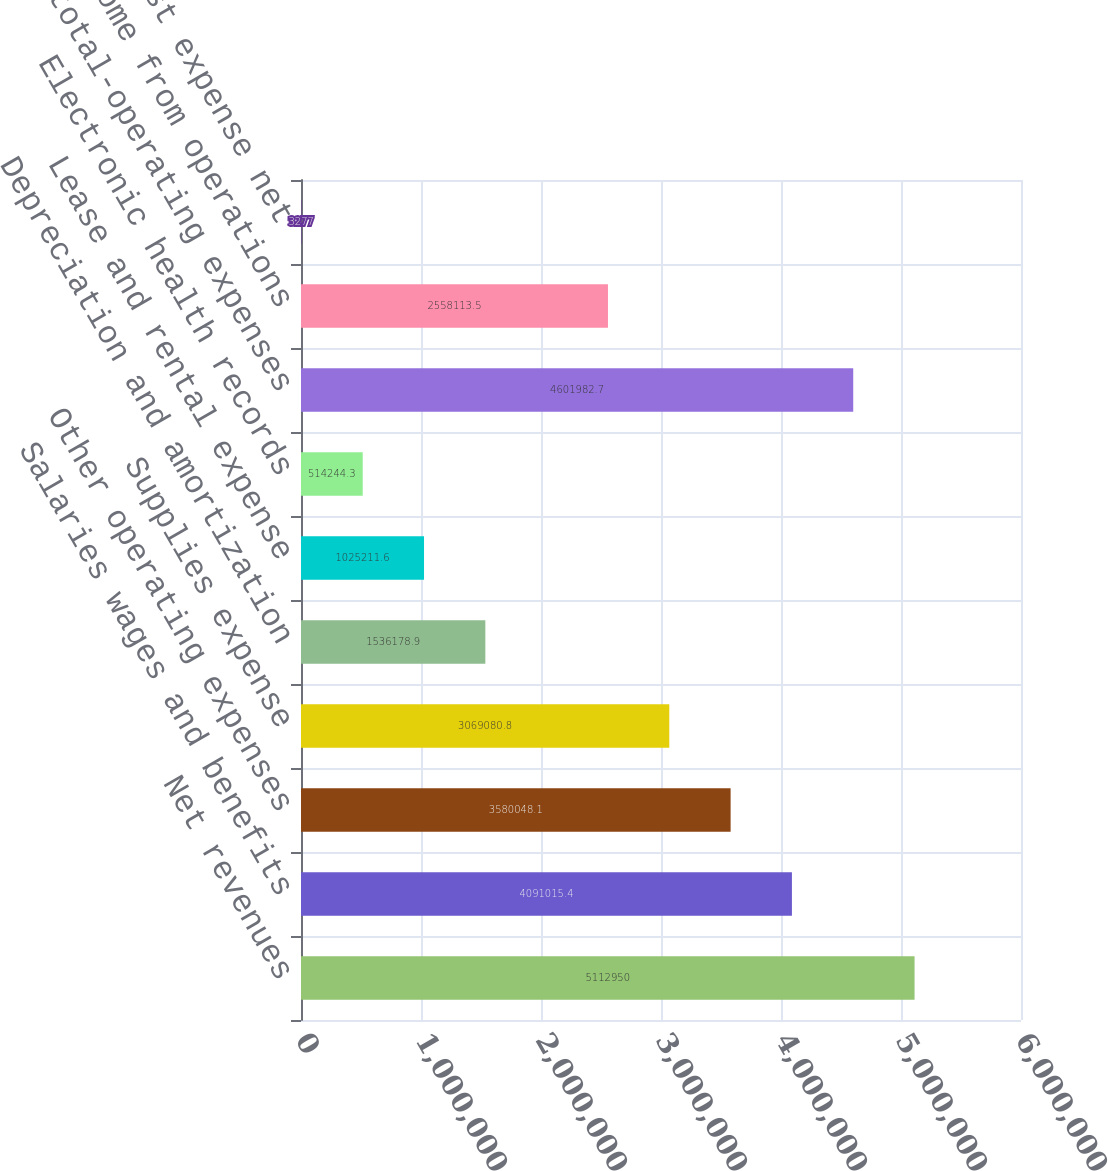Convert chart to OTSL. <chart><loc_0><loc_0><loc_500><loc_500><bar_chart><fcel>Net revenues<fcel>Salaries wages and benefits<fcel>Other operating expenses<fcel>Supplies expense<fcel>Depreciation and amortization<fcel>Lease and rental expense<fcel>Electronic health records<fcel>Subtotal-operating expenses<fcel>Income from operations<fcel>Interest expense net<nl><fcel>5.11295e+06<fcel>4.09102e+06<fcel>3.58005e+06<fcel>3.06908e+06<fcel>1.53618e+06<fcel>1.02521e+06<fcel>514244<fcel>4.60198e+06<fcel>2.55811e+06<fcel>3277<nl></chart> 